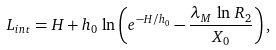<formula> <loc_0><loc_0><loc_500><loc_500>L _ { i n t } = H + h _ { 0 } \, \ln \left ( e ^ { - H / h _ { 0 } } - \frac { \lambda _ { M } \, \ln \, R _ { 2 } } { X _ { 0 } } \right ) ,</formula> 